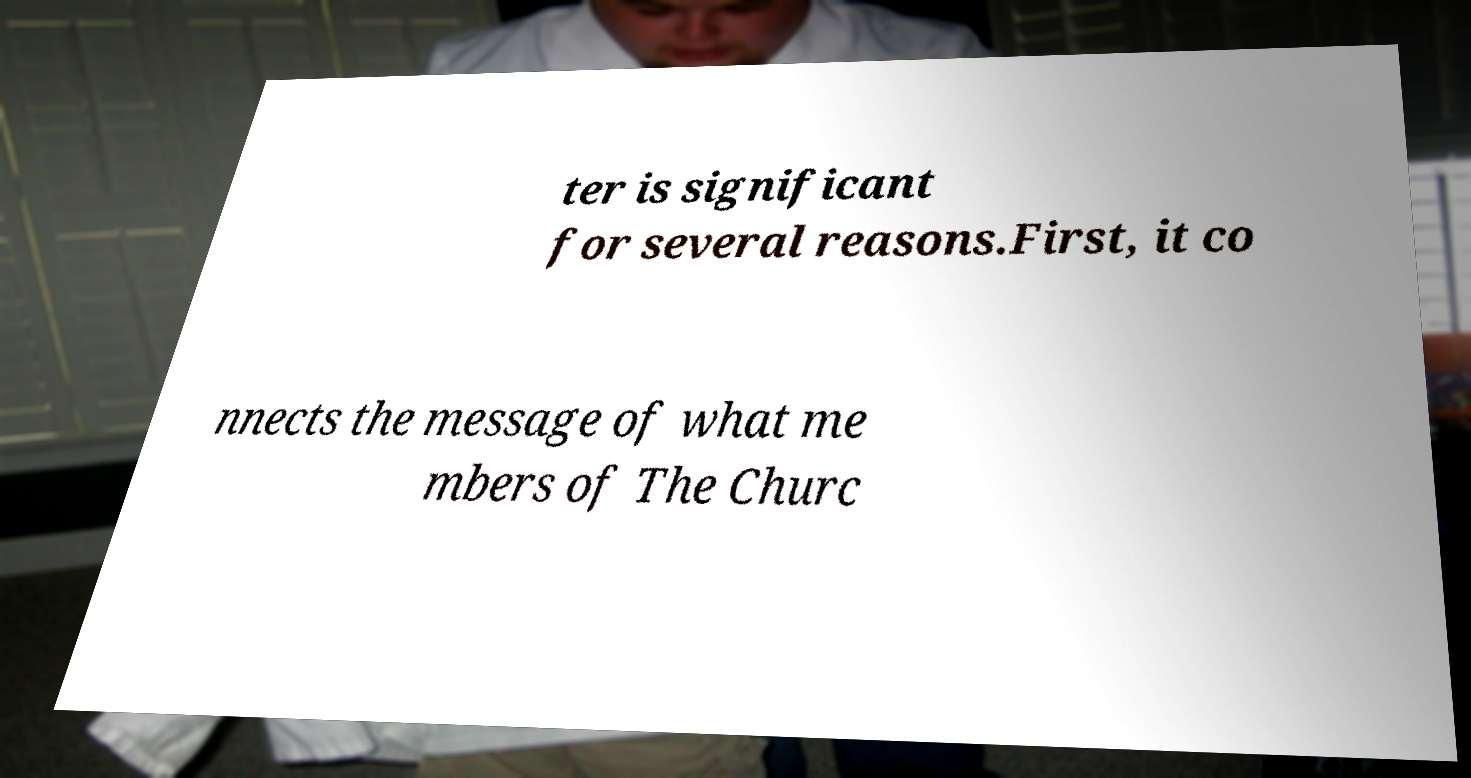For documentation purposes, I need the text within this image transcribed. Could you provide that? ter is significant for several reasons.First, it co nnects the message of what me mbers of The Churc 